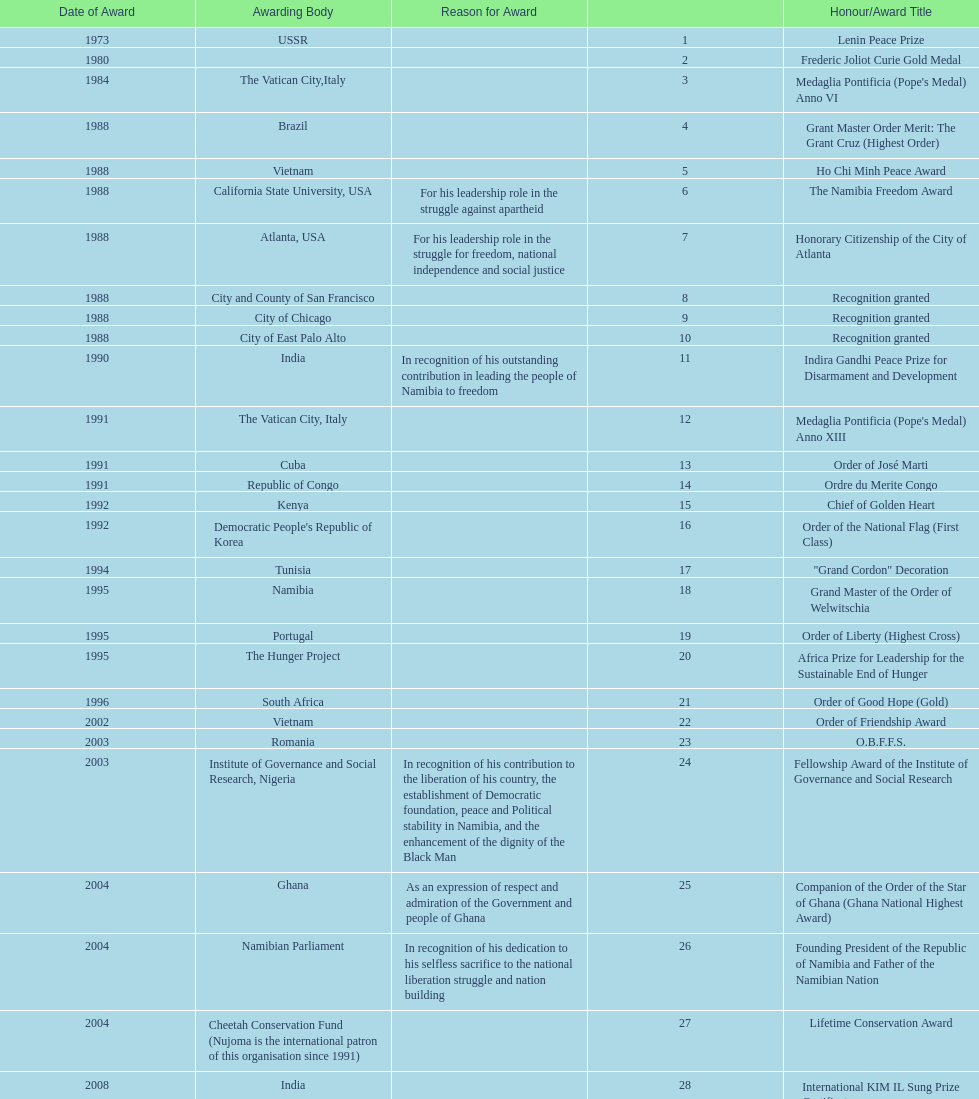Did nujoma win the o.b.f.f.s. award in romania or ghana? Romania. 